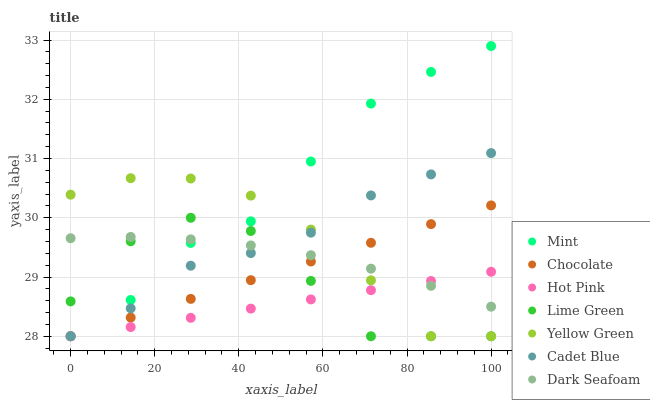Does Hot Pink have the minimum area under the curve?
Answer yes or no. Yes. Does Mint have the maximum area under the curve?
Answer yes or no. Yes. Does Yellow Green have the minimum area under the curve?
Answer yes or no. No. Does Yellow Green have the maximum area under the curve?
Answer yes or no. No. Is Chocolate the smoothest?
Answer yes or no. Yes. Is Lime Green the roughest?
Answer yes or no. Yes. Is Yellow Green the smoothest?
Answer yes or no. No. Is Yellow Green the roughest?
Answer yes or no. No. Does Cadet Blue have the lowest value?
Answer yes or no. Yes. Does Dark Seafoam have the lowest value?
Answer yes or no. No. Does Mint have the highest value?
Answer yes or no. Yes. Does Yellow Green have the highest value?
Answer yes or no. No. Does Chocolate intersect Hot Pink?
Answer yes or no. Yes. Is Chocolate less than Hot Pink?
Answer yes or no. No. Is Chocolate greater than Hot Pink?
Answer yes or no. No. 